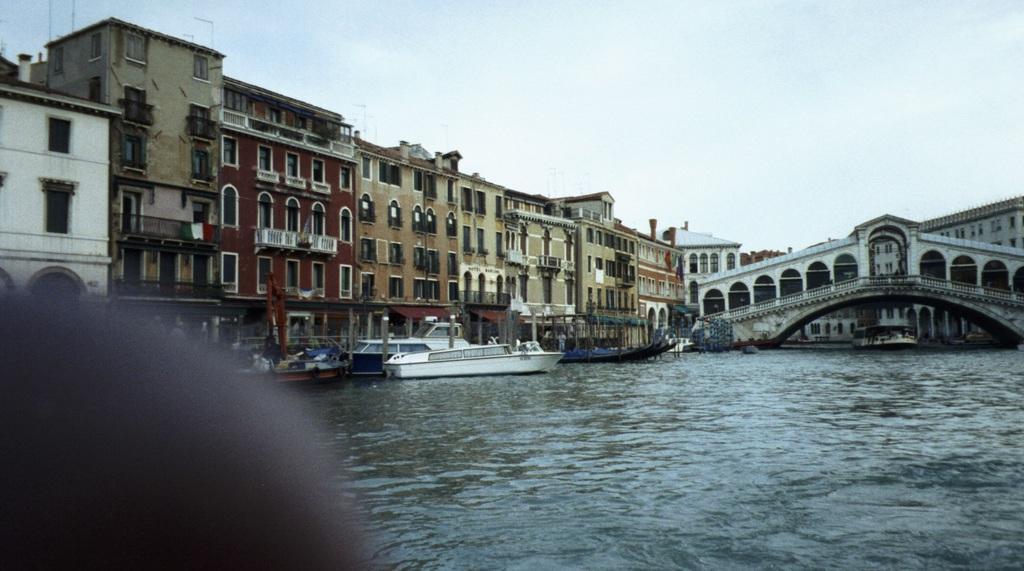In one or two sentences, can you explain what this image depicts? In this image, we can see so many buildings, bridge. Few boats are on the water. Top of the image, there is a sky. 